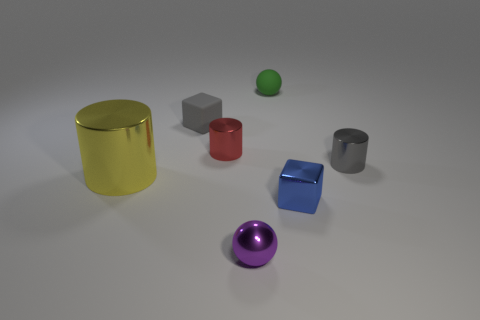Add 2 blue objects. How many objects exist? 9 Subtract all balls. How many objects are left? 5 Add 6 gray matte things. How many gray matte things are left? 7 Add 4 matte spheres. How many matte spheres exist? 5 Subtract 0 red cubes. How many objects are left? 7 Subtract all spheres. Subtract all tiny matte cubes. How many objects are left? 4 